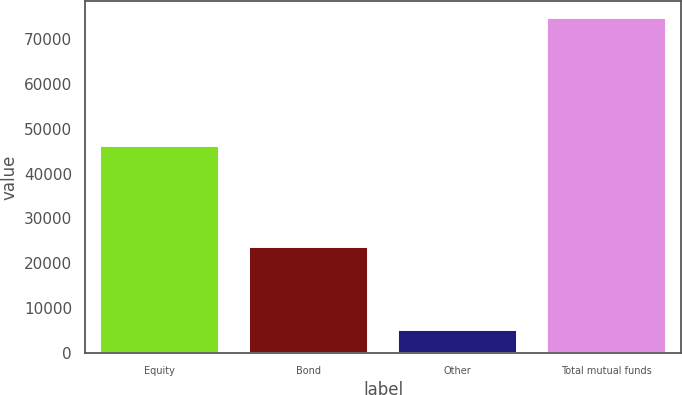Convert chart to OTSL. <chart><loc_0><loc_0><loc_500><loc_500><bar_chart><fcel>Equity<fcel>Bond<fcel>Other<fcel>Total mutual funds<nl><fcel>46038<fcel>23529<fcel>5109<fcel>74676<nl></chart> 